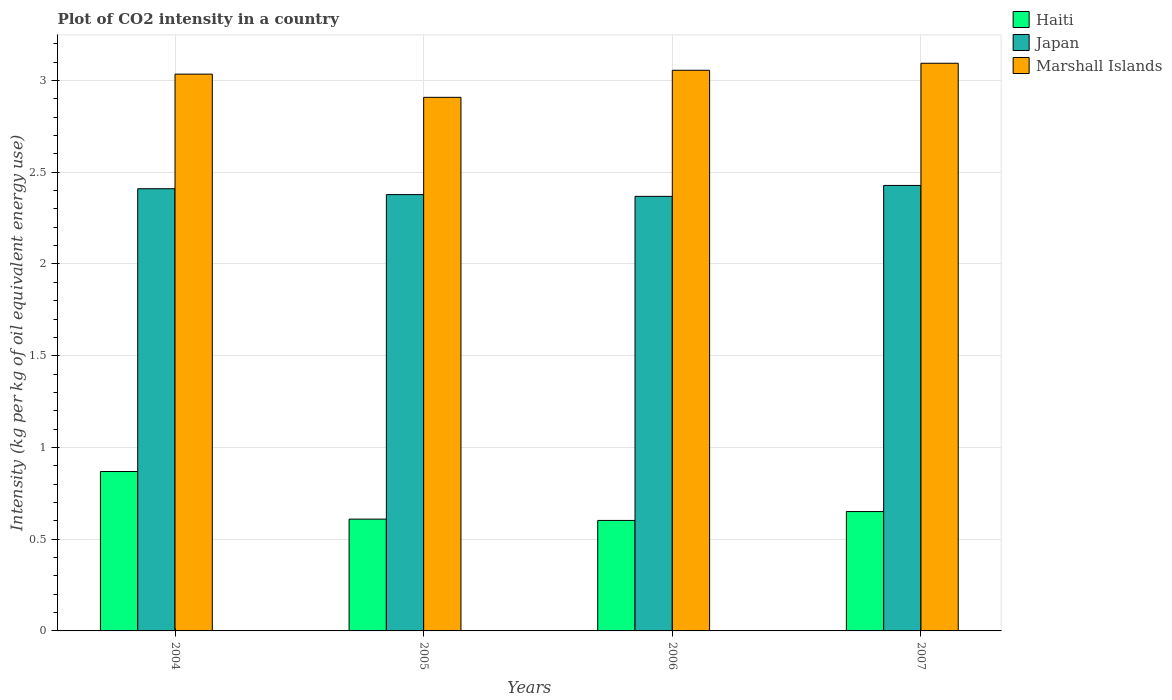How many different coloured bars are there?
Your answer should be very brief. 3. Are the number of bars on each tick of the X-axis equal?
Offer a very short reply. Yes. How many bars are there on the 4th tick from the right?
Your answer should be compact. 3. What is the label of the 3rd group of bars from the left?
Offer a terse response. 2006. What is the CO2 intensity in in Japan in 2004?
Provide a succinct answer. 2.41. Across all years, what is the maximum CO2 intensity in in Japan?
Make the answer very short. 2.43. Across all years, what is the minimum CO2 intensity in in Japan?
Make the answer very short. 2.37. In which year was the CO2 intensity in in Haiti maximum?
Your answer should be very brief. 2004. What is the total CO2 intensity in in Marshall Islands in the graph?
Offer a terse response. 12.09. What is the difference between the CO2 intensity in in Haiti in 2006 and that in 2007?
Your answer should be compact. -0.05. What is the difference between the CO2 intensity in in Haiti in 2007 and the CO2 intensity in in Japan in 2004?
Offer a terse response. -1.76. What is the average CO2 intensity in in Haiti per year?
Provide a succinct answer. 0.68. In the year 2005, what is the difference between the CO2 intensity in in Japan and CO2 intensity in in Haiti?
Ensure brevity in your answer.  1.77. In how many years, is the CO2 intensity in in Marshall Islands greater than 1.5 kg?
Offer a very short reply. 4. What is the ratio of the CO2 intensity in in Marshall Islands in 2004 to that in 2007?
Your response must be concise. 0.98. Is the difference between the CO2 intensity in in Japan in 2005 and 2007 greater than the difference between the CO2 intensity in in Haiti in 2005 and 2007?
Make the answer very short. No. What is the difference between the highest and the second highest CO2 intensity in in Japan?
Ensure brevity in your answer.  0.02. What is the difference between the highest and the lowest CO2 intensity in in Marshall Islands?
Offer a terse response. 0.19. What does the 3rd bar from the left in 2007 represents?
Keep it short and to the point. Marshall Islands. What does the 3rd bar from the right in 2004 represents?
Your answer should be very brief. Haiti. How many bars are there?
Offer a very short reply. 12. What is the difference between two consecutive major ticks on the Y-axis?
Keep it short and to the point. 0.5. Are the values on the major ticks of Y-axis written in scientific E-notation?
Give a very brief answer. No. Does the graph contain grids?
Offer a very short reply. Yes. What is the title of the graph?
Ensure brevity in your answer.  Plot of CO2 intensity in a country. What is the label or title of the X-axis?
Offer a terse response. Years. What is the label or title of the Y-axis?
Give a very brief answer. Intensity (kg per kg of oil equivalent energy use). What is the Intensity (kg per kg of oil equivalent energy use) of Haiti in 2004?
Give a very brief answer. 0.87. What is the Intensity (kg per kg of oil equivalent energy use) of Japan in 2004?
Offer a very short reply. 2.41. What is the Intensity (kg per kg of oil equivalent energy use) of Marshall Islands in 2004?
Offer a terse response. 3.03. What is the Intensity (kg per kg of oil equivalent energy use) in Haiti in 2005?
Your answer should be very brief. 0.61. What is the Intensity (kg per kg of oil equivalent energy use) of Japan in 2005?
Ensure brevity in your answer.  2.38. What is the Intensity (kg per kg of oil equivalent energy use) of Marshall Islands in 2005?
Your answer should be very brief. 2.91. What is the Intensity (kg per kg of oil equivalent energy use) in Haiti in 2006?
Your answer should be very brief. 0.6. What is the Intensity (kg per kg of oil equivalent energy use) in Japan in 2006?
Your answer should be very brief. 2.37. What is the Intensity (kg per kg of oil equivalent energy use) in Marshall Islands in 2006?
Make the answer very short. 3.06. What is the Intensity (kg per kg of oil equivalent energy use) in Haiti in 2007?
Provide a short and direct response. 0.65. What is the Intensity (kg per kg of oil equivalent energy use) in Japan in 2007?
Offer a very short reply. 2.43. What is the Intensity (kg per kg of oil equivalent energy use) of Marshall Islands in 2007?
Provide a succinct answer. 3.09. Across all years, what is the maximum Intensity (kg per kg of oil equivalent energy use) of Haiti?
Offer a very short reply. 0.87. Across all years, what is the maximum Intensity (kg per kg of oil equivalent energy use) of Japan?
Offer a terse response. 2.43. Across all years, what is the maximum Intensity (kg per kg of oil equivalent energy use) of Marshall Islands?
Provide a short and direct response. 3.09. Across all years, what is the minimum Intensity (kg per kg of oil equivalent energy use) of Haiti?
Your answer should be compact. 0.6. Across all years, what is the minimum Intensity (kg per kg of oil equivalent energy use) of Japan?
Keep it short and to the point. 2.37. Across all years, what is the minimum Intensity (kg per kg of oil equivalent energy use) of Marshall Islands?
Your response must be concise. 2.91. What is the total Intensity (kg per kg of oil equivalent energy use) of Haiti in the graph?
Offer a terse response. 2.73. What is the total Intensity (kg per kg of oil equivalent energy use) of Japan in the graph?
Make the answer very short. 9.58. What is the total Intensity (kg per kg of oil equivalent energy use) in Marshall Islands in the graph?
Offer a very short reply. 12.09. What is the difference between the Intensity (kg per kg of oil equivalent energy use) of Haiti in 2004 and that in 2005?
Offer a very short reply. 0.26. What is the difference between the Intensity (kg per kg of oil equivalent energy use) of Japan in 2004 and that in 2005?
Make the answer very short. 0.03. What is the difference between the Intensity (kg per kg of oil equivalent energy use) in Marshall Islands in 2004 and that in 2005?
Your answer should be very brief. 0.13. What is the difference between the Intensity (kg per kg of oil equivalent energy use) in Haiti in 2004 and that in 2006?
Offer a very short reply. 0.27. What is the difference between the Intensity (kg per kg of oil equivalent energy use) of Japan in 2004 and that in 2006?
Ensure brevity in your answer.  0.04. What is the difference between the Intensity (kg per kg of oil equivalent energy use) in Marshall Islands in 2004 and that in 2006?
Keep it short and to the point. -0.02. What is the difference between the Intensity (kg per kg of oil equivalent energy use) of Haiti in 2004 and that in 2007?
Your answer should be very brief. 0.22. What is the difference between the Intensity (kg per kg of oil equivalent energy use) in Japan in 2004 and that in 2007?
Offer a terse response. -0.02. What is the difference between the Intensity (kg per kg of oil equivalent energy use) of Marshall Islands in 2004 and that in 2007?
Give a very brief answer. -0.06. What is the difference between the Intensity (kg per kg of oil equivalent energy use) in Haiti in 2005 and that in 2006?
Ensure brevity in your answer.  0.01. What is the difference between the Intensity (kg per kg of oil equivalent energy use) of Japan in 2005 and that in 2006?
Make the answer very short. 0.01. What is the difference between the Intensity (kg per kg of oil equivalent energy use) of Marshall Islands in 2005 and that in 2006?
Make the answer very short. -0.15. What is the difference between the Intensity (kg per kg of oil equivalent energy use) of Haiti in 2005 and that in 2007?
Offer a terse response. -0.04. What is the difference between the Intensity (kg per kg of oil equivalent energy use) of Japan in 2005 and that in 2007?
Your answer should be very brief. -0.05. What is the difference between the Intensity (kg per kg of oil equivalent energy use) in Marshall Islands in 2005 and that in 2007?
Your response must be concise. -0.19. What is the difference between the Intensity (kg per kg of oil equivalent energy use) in Haiti in 2006 and that in 2007?
Offer a terse response. -0.05. What is the difference between the Intensity (kg per kg of oil equivalent energy use) of Japan in 2006 and that in 2007?
Your answer should be compact. -0.06. What is the difference between the Intensity (kg per kg of oil equivalent energy use) of Marshall Islands in 2006 and that in 2007?
Your answer should be compact. -0.04. What is the difference between the Intensity (kg per kg of oil equivalent energy use) of Haiti in 2004 and the Intensity (kg per kg of oil equivalent energy use) of Japan in 2005?
Your response must be concise. -1.51. What is the difference between the Intensity (kg per kg of oil equivalent energy use) of Haiti in 2004 and the Intensity (kg per kg of oil equivalent energy use) of Marshall Islands in 2005?
Your answer should be very brief. -2.04. What is the difference between the Intensity (kg per kg of oil equivalent energy use) in Japan in 2004 and the Intensity (kg per kg of oil equivalent energy use) in Marshall Islands in 2005?
Offer a terse response. -0.5. What is the difference between the Intensity (kg per kg of oil equivalent energy use) in Haiti in 2004 and the Intensity (kg per kg of oil equivalent energy use) in Japan in 2006?
Your answer should be very brief. -1.5. What is the difference between the Intensity (kg per kg of oil equivalent energy use) in Haiti in 2004 and the Intensity (kg per kg of oil equivalent energy use) in Marshall Islands in 2006?
Offer a terse response. -2.19. What is the difference between the Intensity (kg per kg of oil equivalent energy use) of Japan in 2004 and the Intensity (kg per kg of oil equivalent energy use) of Marshall Islands in 2006?
Your answer should be very brief. -0.65. What is the difference between the Intensity (kg per kg of oil equivalent energy use) of Haiti in 2004 and the Intensity (kg per kg of oil equivalent energy use) of Japan in 2007?
Offer a very short reply. -1.56. What is the difference between the Intensity (kg per kg of oil equivalent energy use) of Haiti in 2004 and the Intensity (kg per kg of oil equivalent energy use) of Marshall Islands in 2007?
Make the answer very short. -2.23. What is the difference between the Intensity (kg per kg of oil equivalent energy use) of Japan in 2004 and the Intensity (kg per kg of oil equivalent energy use) of Marshall Islands in 2007?
Provide a succinct answer. -0.68. What is the difference between the Intensity (kg per kg of oil equivalent energy use) of Haiti in 2005 and the Intensity (kg per kg of oil equivalent energy use) of Japan in 2006?
Ensure brevity in your answer.  -1.76. What is the difference between the Intensity (kg per kg of oil equivalent energy use) of Haiti in 2005 and the Intensity (kg per kg of oil equivalent energy use) of Marshall Islands in 2006?
Ensure brevity in your answer.  -2.45. What is the difference between the Intensity (kg per kg of oil equivalent energy use) of Japan in 2005 and the Intensity (kg per kg of oil equivalent energy use) of Marshall Islands in 2006?
Offer a terse response. -0.68. What is the difference between the Intensity (kg per kg of oil equivalent energy use) in Haiti in 2005 and the Intensity (kg per kg of oil equivalent energy use) in Japan in 2007?
Ensure brevity in your answer.  -1.82. What is the difference between the Intensity (kg per kg of oil equivalent energy use) in Haiti in 2005 and the Intensity (kg per kg of oil equivalent energy use) in Marshall Islands in 2007?
Ensure brevity in your answer.  -2.48. What is the difference between the Intensity (kg per kg of oil equivalent energy use) in Japan in 2005 and the Intensity (kg per kg of oil equivalent energy use) in Marshall Islands in 2007?
Your answer should be compact. -0.72. What is the difference between the Intensity (kg per kg of oil equivalent energy use) in Haiti in 2006 and the Intensity (kg per kg of oil equivalent energy use) in Japan in 2007?
Offer a very short reply. -1.83. What is the difference between the Intensity (kg per kg of oil equivalent energy use) in Haiti in 2006 and the Intensity (kg per kg of oil equivalent energy use) in Marshall Islands in 2007?
Keep it short and to the point. -2.49. What is the difference between the Intensity (kg per kg of oil equivalent energy use) of Japan in 2006 and the Intensity (kg per kg of oil equivalent energy use) of Marshall Islands in 2007?
Offer a very short reply. -0.73. What is the average Intensity (kg per kg of oil equivalent energy use) in Haiti per year?
Your response must be concise. 0.68. What is the average Intensity (kg per kg of oil equivalent energy use) in Japan per year?
Your answer should be very brief. 2.4. What is the average Intensity (kg per kg of oil equivalent energy use) in Marshall Islands per year?
Your answer should be very brief. 3.02. In the year 2004, what is the difference between the Intensity (kg per kg of oil equivalent energy use) in Haiti and Intensity (kg per kg of oil equivalent energy use) in Japan?
Your answer should be very brief. -1.54. In the year 2004, what is the difference between the Intensity (kg per kg of oil equivalent energy use) of Haiti and Intensity (kg per kg of oil equivalent energy use) of Marshall Islands?
Provide a succinct answer. -2.17. In the year 2004, what is the difference between the Intensity (kg per kg of oil equivalent energy use) in Japan and Intensity (kg per kg of oil equivalent energy use) in Marshall Islands?
Offer a very short reply. -0.62. In the year 2005, what is the difference between the Intensity (kg per kg of oil equivalent energy use) of Haiti and Intensity (kg per kg of oil equivalent energy use) of Japan?
Ensure brevity in your answer.  -1.77. In the year 2005, what is the difference between the Intensity (kg per kg of oil equivalent energy use) in Haiti and Intensity (kg per kg of oil equivalent energy use) in Marshall Islands?
Provide a succinct answer. -2.3. In the year 2005, what is the difference between the Intensity (kg per kg of oil equivalent energy use) in Japan and Intensity (kg per kg of oil equivalent energy use) in Marshall Islands?
Provide a succinct answer. -0.53. In the year 2006, what is the difference between the Intensity (kg per kg of oil equivalent energy use) of Haiti and Intensity (kg per kg of oil equivalent energy use) of Japan?
Give a very brief answer. -1.77. In the year 2006, what is the difference between the Intensity (kg per kg of oil equivalent energy use) in Haiti and Intensity (kg per kg of oil equivalent energy use) in Marshall Islands?
Ensure brevity in your answer.  -2.45. In the year 2006, what is the difference between the Intensity (kg per kg of oil equivalent energy use) of Japan and Intensity (kg per kg of oil equivalent energy use) of Marshall Islands?
Provide a succinct answer. -0.69. In the year 2007, what is the difference between the Intensity (kg per kg of oil equivalent energy use) in Haiti and Intensity (kg per kg of oil equivalent energy use) in Japan?
Ensure brevity in your answer.  -1.78. In the year 2007, what is the difference between the Intensity (kg per kg of oil equivalent energy use) in Haiti and Intensity (kg per kg of oil equivalent energy use) in Marshall Islands?
Provide a succinct answer. -2.44. In the year 2007, what is the difference between the Intensity (kg per kg of oil equivalent energy use) in Japan and Intensity (kg per kg of oil equivalent energy use) in Marshall Islands?
Provide a short and direct response. -0.67. What is the ratio of the Intensity (kg per kg of oil equivalent energy use) of Haiti in 2004 to that in 2005?
Provide a succinct answer. 1.43. What is the ratio of the Intensity (kg per kg of oil equivalent energy use) in Japan in 2004 to that in 2005?
Offer a very short reply. 1.01. What is the ratio of the Intensity (kg per kg of oil equivalent energy use) of Marshall Islands in 2004 to that in 2005?
Provide a short and direct response. 1.04. What is the ratio of the Intensity (kg per kg of oil equivalent energy use) in Haiti in 2004 to that in 2006?
Ensure brevity in your answer.  1.44. What is the ratio of the Intensity (kg per kg of oil equivalent energy use) in Japan in 2004 to that in 2006?
Give a very brief answer. 1.02. What is the ratio of the Intensity (kg per kg of oil equivalent energy use) in Haiti in 2004 to that in 2007?
Ensure brevity in your answer.  1.34. What is the ratio of the Intensity (kg per kg of oil equivalent energy use) of Marshall Islands in 2004 to that in 2007?
Offer a terse response. 0.98. What is the ratio of the Intensity (kg per kg of oil equivalent energy use) of Haiti in 2005 to that in 2006?
Provide a short and direct response. 1.01. What is the ratio of the Intensity (kg per kg of oil equivalent energy use) in Marshall Islands in 2005 to that in 2006?
Give a very brief answer. 0.95. What is the ratio of the Intensity (kg per kg of oil equivalent energy use) in Haiti in 2005 to that in 2007?
Give a very brief answer. 0.94. What is the ratio of the Intensity (kg per kg of oil equivalent energy use) in Japan in 2005 to that in 2007?
Offer a terse response. 0.98. What is the ratio of the Intensity (kg per kg of oil equivalent energy use) of Marshall Islands in 2005 to that in 2007?
Provide a succinct answer. 0.94. What is the ratio of the Intensity (kg per kg of oil equivalent energy use) in Haiti in 2006 to that in 2007?
Your answer should be compact. 0.93. What is the ratio of the Intensity (kg per kg of oil equivalent energy use) of Japan in 2006 to that in 2007?
Make the answer very short. 0.98. What is the ratio of the Intensity (kg per kg of oil equivalent energy use) of Marshall Islands in 2006 to that in 2007?
Provide a succinct answer. 0.99. What is the difference between the highest and the second highest Intensity (kg per kg of oil equivalent energy use) in Haiti?
Provide a succinct answer. 0.22. What is the difference between the highest and the second highest Intensity (kg per kg of oil equivalent energy use) in Japan?
Your answer should be compact. 0.02. What is the difference between the highest and the second highest Intensity (kg per kg of oil equivalent energy use) in Marshall Islands?
Offer a terse response. 0.04. What is the difference between the highest and the lowest Intensity (kg per kg of oil equivalent energy use) of Haiti?
Provide a succinct answer. 0.27. What is the difference between the highest and the lowest Intensity (kg per kg of oil equivalent energy use) in Japan?
Give a very brief answer. 0.06. What is the difference between the highest and the lowest Intensity (kg per kg of oil equivalent energy use) in Marshall Islands?
Your answer should be very brief. 0.19. 